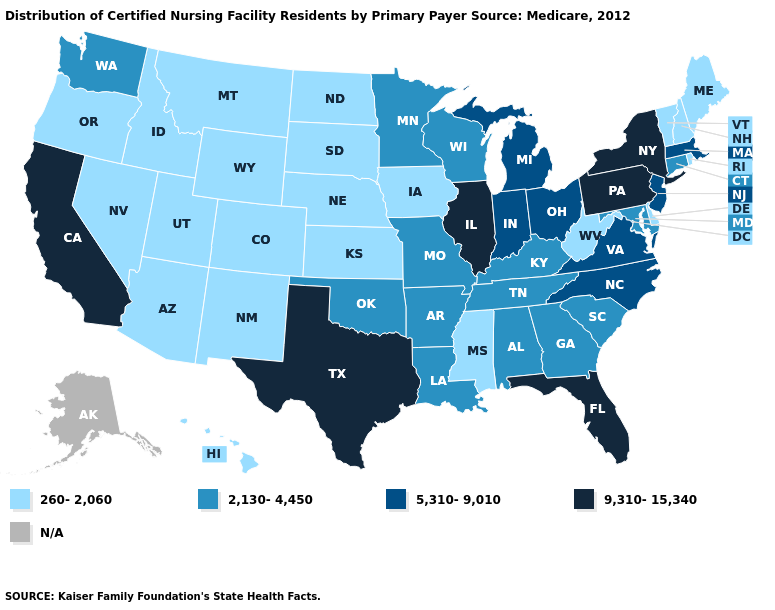Does the first symbol in the legend represent the smallest category?
Write a very short answer. Yes. What is the value of Rhode Island?
Concise answer only. 260-2,060. What is the value of North Carolina?
Concise answer only. 5,310-9,010. What is the lowest value in the USA?
Give a very brief answer. 260-2,060. Does the map have missing data?
Short answer required. Yes. Name the states that have a value in the range 5,310-9,010?
Quick response, please. Indiana, Massachusetts, Michigan, New Jersey, North Carolina, Ohio, Virginia. What is the value of Louisiana?
Quick response, please. 2,130-4,450. What is the value of Maryland?
Write a very short answer. 2,130-4,450. Name the states that have a value in the range 2,130-4,450?
Concise answer only. Alabama, Arkansas, Connecticut, Georgia, Kentucky, Louisiana, Maryland, Minnesota, Missouri, Oklahoma, South Carolina, Tennessee, Washington, Wisconsin. What is the highest value in the USA?
Answer briefly. 9,310-15,340. Does Wyoming have the lowest value in the USA?
Give a very brief answer. Yes. Is the legend a continuous bar?
Answer briefly. No. Among the states that border Connecticut , does Rhode Island have the lowest value?
Give a very brief answer. Yes. Among the states that border Georgia , which have the highest value?
Write a very short answer. Florida. 